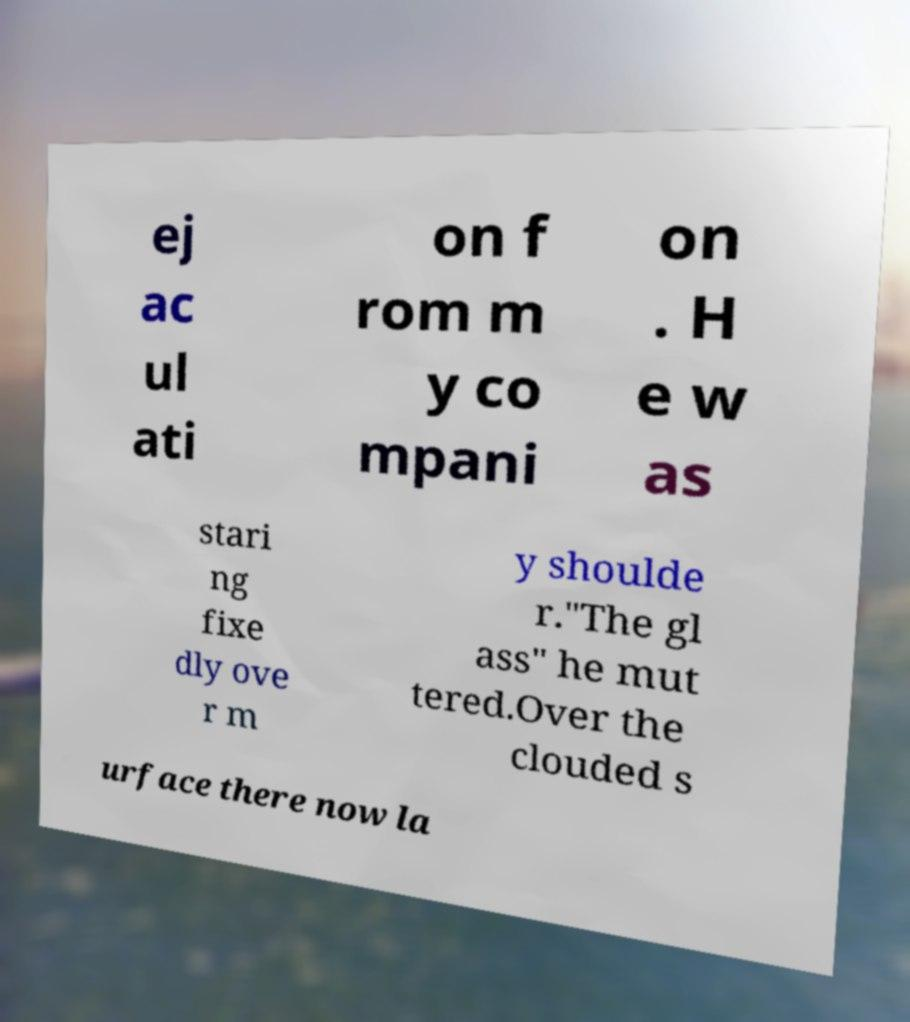Can you read and provide the text displayed in the image?This photo seems to have some interesting text. Can you extract and type it out for me? ej ac ul ati on f rom m y co mpani on . H e w as stari ng fixe dly ove r m y shoulde r."The gl ass" he mut tered.Over the clouded s urface there now la 